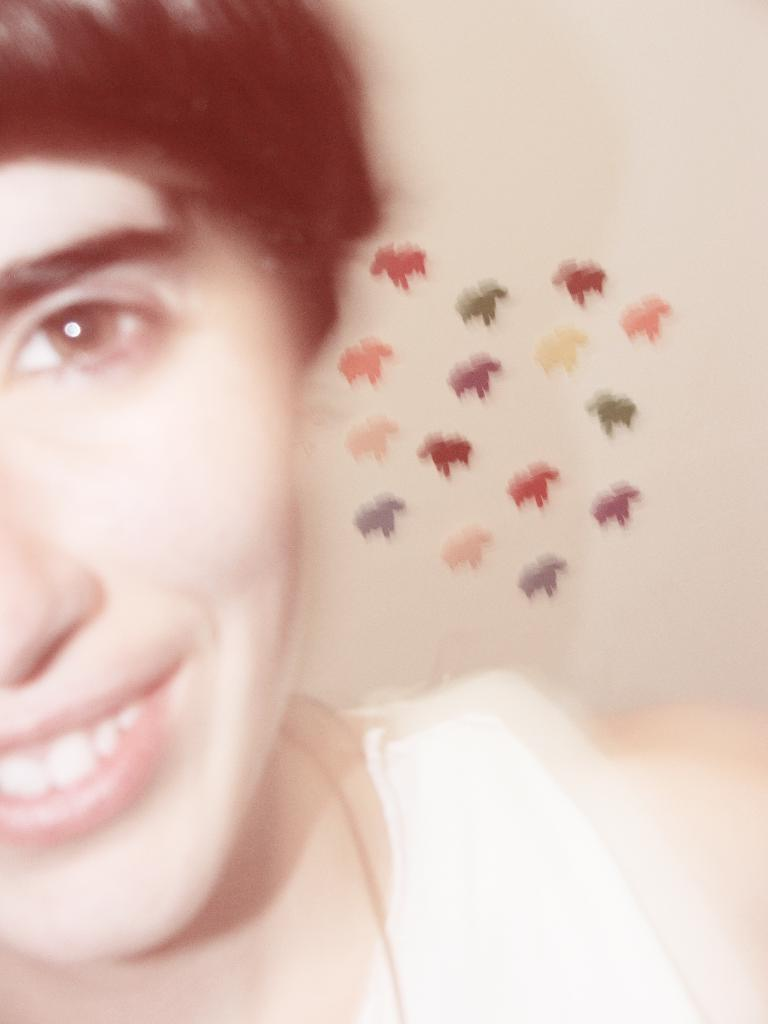What is the main subject of the image? There is a person in the image. What can be seen on the wall in the image? There are sticker-like objects on the wall in the image. What type of tooth is visible in the image? There is no tooth present in the image. Where is the cave located in the image? There is no cave present in the image. 